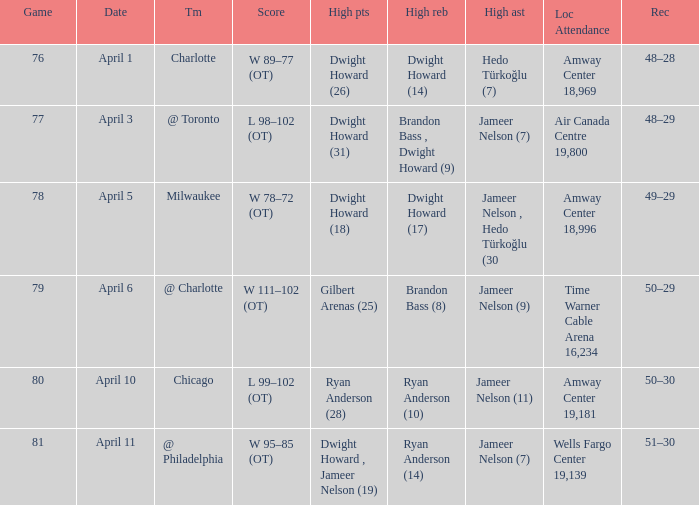What was the location of the game and the attendance figure on april 3? Air Canada Centre 19,800. 